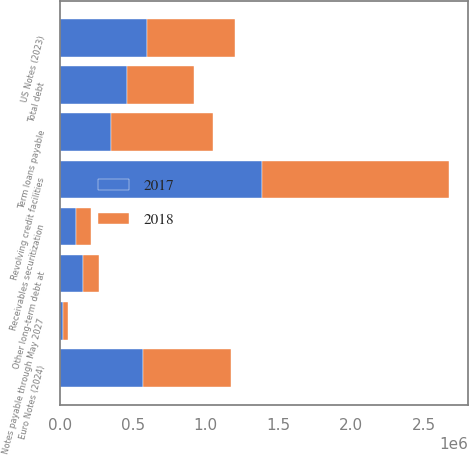Convert chart. <chart><loc_0><loc_0><loc_500><loc_500><stacked_bar_chart><ecel><fcel>Term loans payable<fcel>Revolving credit facilities<fcel>US Notes (2023)<fcel>Euro Notes (2024)<fcel>Receivables securitization<fcel>Notes payable through May 2027<fcel>Other long-term debt at<fcel>Total debt<nl><fcel>2017<fcel>350000<fcel>1.38718e+06<fcel>600000<fcel>573350<fcel>110000<fcel>23056<fcel>157414<fcel>461675<nl><fcel>2018<fcel>704800<fcel>1.28355e+06<fcel>600000<fcel>600150<fcel>100000<fcel>29146<fcel>110633<fcel>461675<nl></chart> 